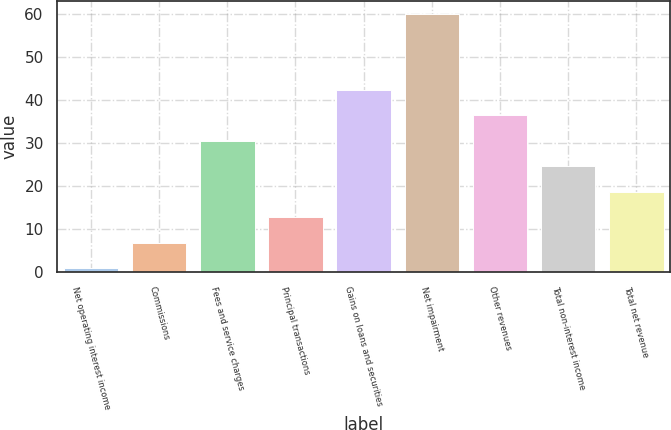Convert chart to OTSL. <chart><loc_0><loc_0><loc_500><loc_500><bar_chart><fcel>Net operating interest income<fcel>Commissions<fcel>Fees and service charges<fcel>Principal transactions<fcel>Gains on loans and securities<fcel>Net impairment<fcel>Other revenues<fcel>Total non-interest income<fcel>Total net revenue<nl><fcel>1<fcel>6.9<fcel>30.5<fcel>12.8<fcel>42.3<fcel>60<fcel>36.4<fcel>24.6<fcel>18.7<nl></chart> 